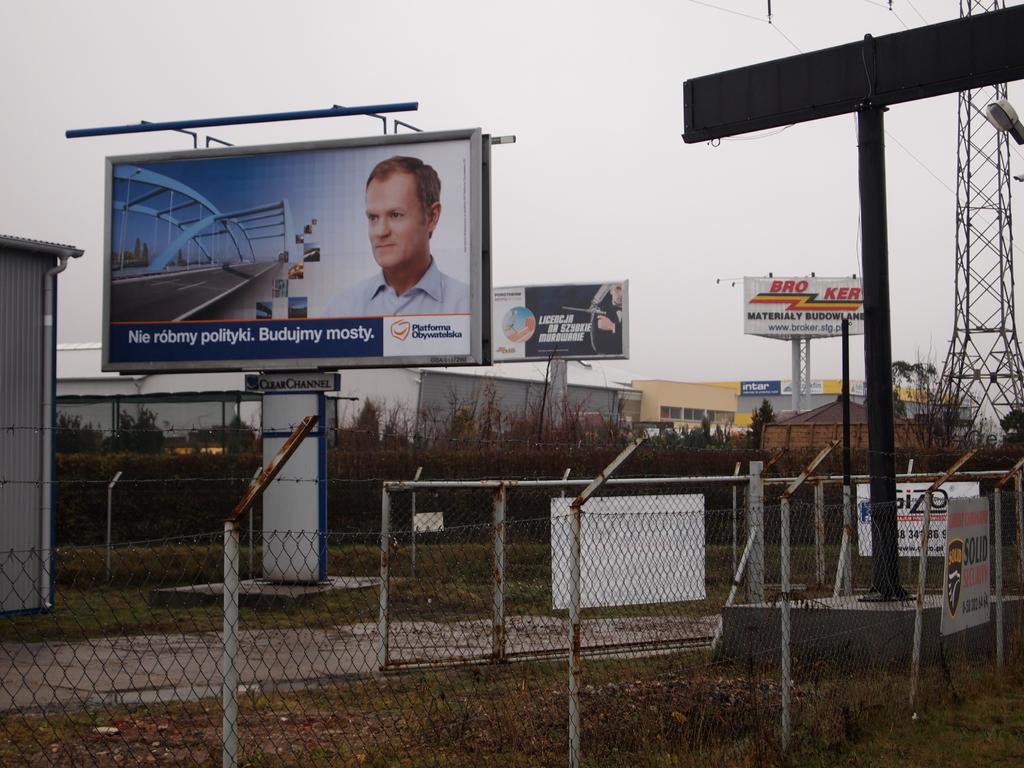What is the white billboard in background for?
Ensure brevity in your answer.  Unanswerable. 